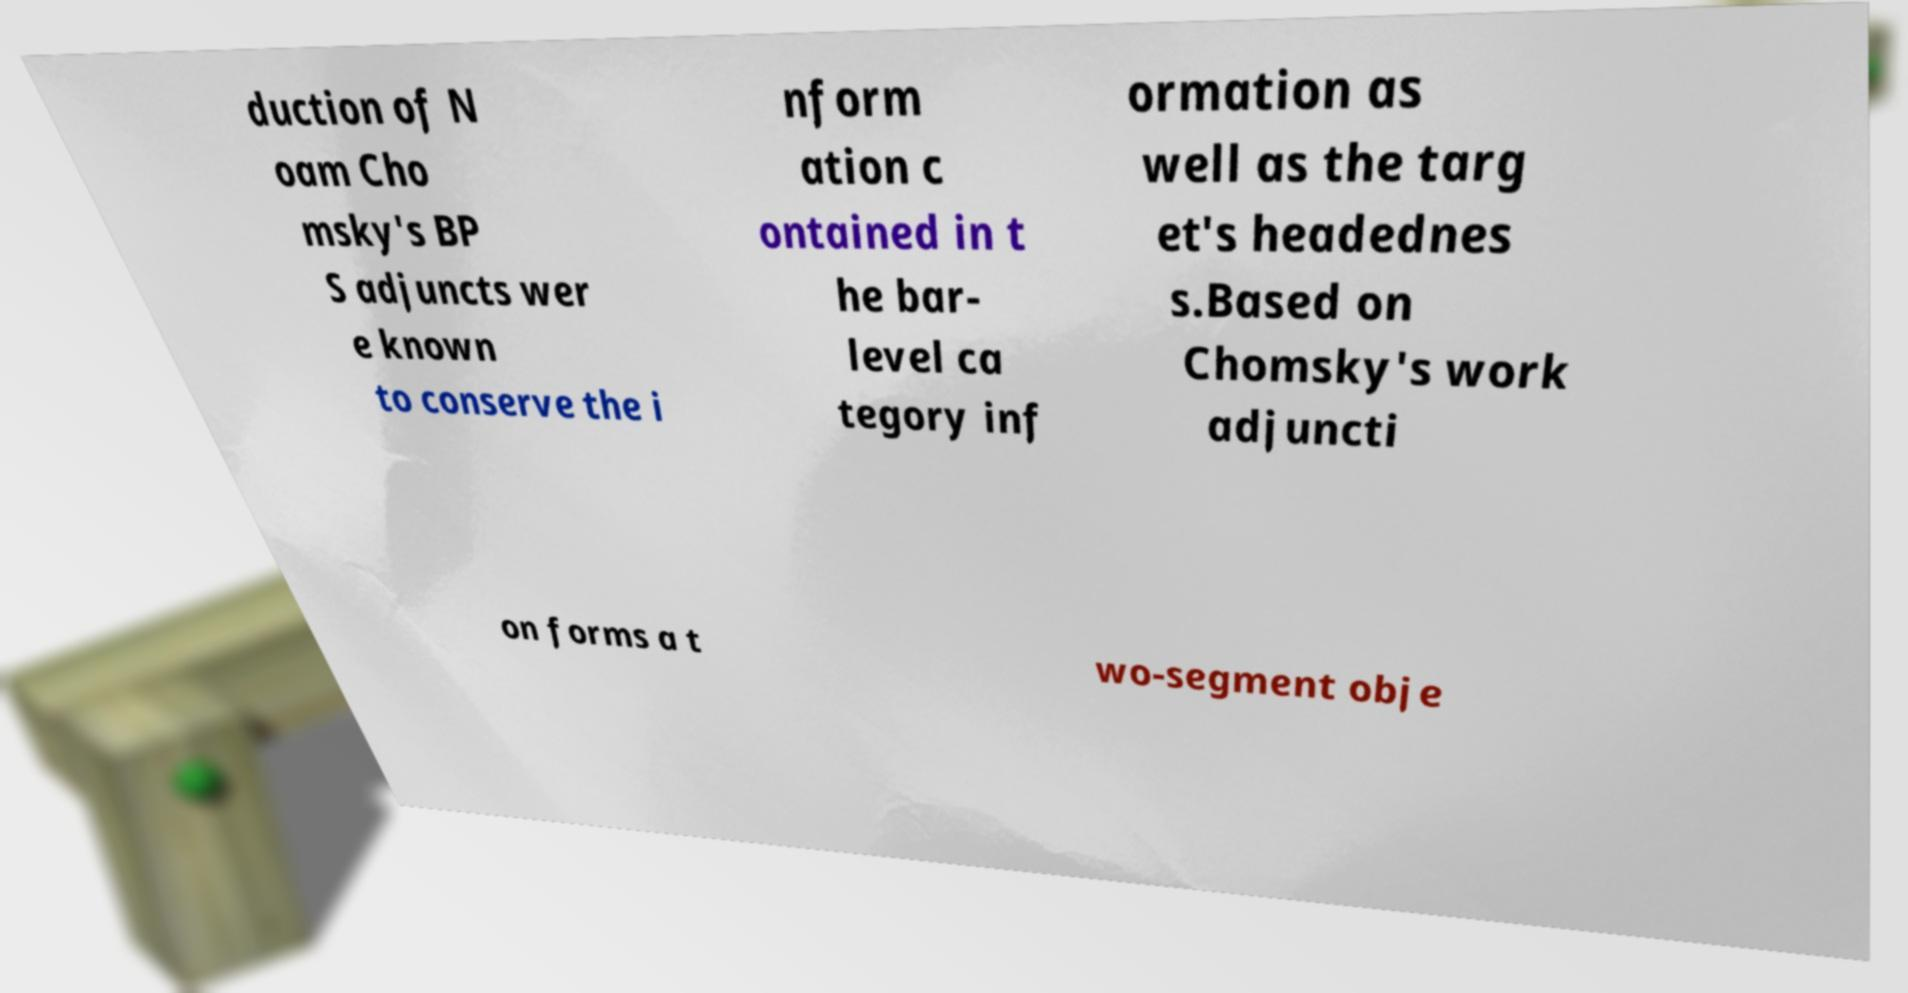Can you read and provide the text displayed in the image?This photo seems to have some interesting text. Can you extract and type it out for me? duction of N oam Cho msky's BP S adjuncts wer e known to conserve the i nform ation c ontained in t he bar- level ca tegory inf ormation as well as the targ et's headednes s.Based on Chomsky's work adjuncti on forms a t wo-segment obje 